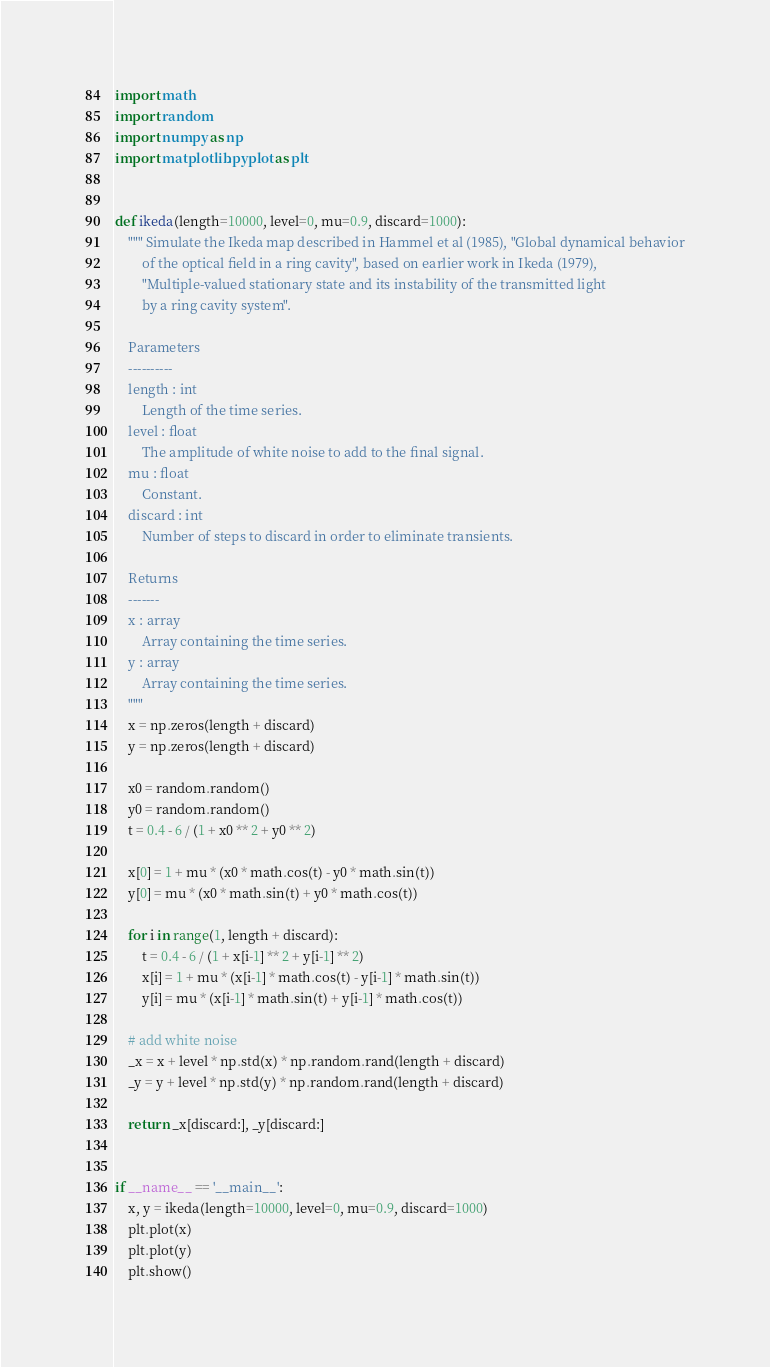Convert code to text. <code><loc_0><loc_0><loc_500><loc_500><_Python_>import math
import random
import numpy as np
import matplotlib.pyplot as plt


def ikeda(length=10000, level=0, mu=0.9, discard=1000):
    """ Simulate the Ikeda map described in Hammel et al (1985), "Global dynamical behavior
        of the optical field in a ring cavity", based on earlier work in Ikeda (1979),
        "Multiple-valued stationary state and its instability of the transmitted light
        by a ring cavity system".

    Parameters
    ----------
    length : int
        Length of the time series.
    level : float
        The amplitude of white noise to add to the final signal.
    mu : float
        Constant.
    discard : int
        Number of steps to discard in order to eliminate transients.

    Returns
    -------
    x : array
        Array containing the time series.
    y : array
        Array containing the time series.
    """
    x = np.zeros(length + discard)
    y = np.zeros(length + discard)

    x0 = random.random()
    y0 = random.random()
    t = 0.4 - 6 / (1 + x0 ** 2 + y0 ** 2)

    x[0] = 1 + mu * (x0 * math.cos(t) - y0 * math.sin(t))
    y[0] = mu * (x0 * math.sin(t) + y0 * math.cos(t))

    for i in range(1, length + discard):
        t = 0.4 - 6 / (1 + x[i-1] ** 2 + y[i-1] ** 2)
        x[i] = 1 + mu * (x[i-1] * math.cos(t) - y[i-1] * math.sin(t))
        y[i] = mu * (x[i-1] * math.sin(t) + y[i-1] * math.cos(t))

    # add white noise
    _x = x + level * np.std(x) * np.random.rand(length + discard)
    _y = y + level * np.std(y) * np.random.rand(length + discard)

    return _x[discard:], _y[discard:]


if __name__ == '__main__':
    x, y = ikeda(length=10000, level=0, mu=0.9, discard=1000)
    plt.plot(x)
    plt.plot(y)
    plt.show()
</code> 